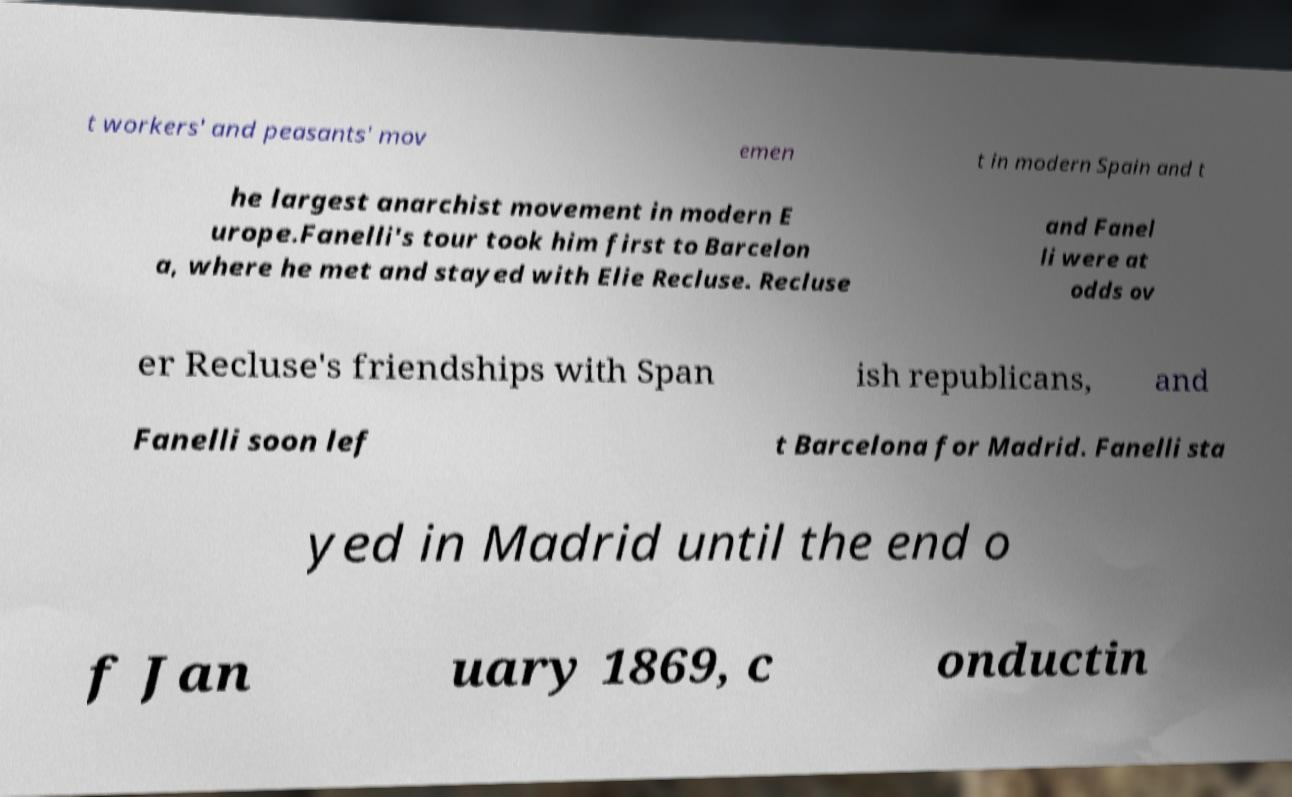What messages or text are displayed in this image? I need them in a readable, typed format. t workers' and peasants' mov emen t in modern Spain and t he largest anarchist movement in modern E urope.Fanelli's tour took him first to Barcelon a, where he met and stayed with Elie Recluse. Recluse and Fanel li were at odds ov er Recluse's friendships with Span ish republicans, and Fanelli soon lef t Barcelona for Madrid. Fanelli sta yed in Madrid until the end o f Jan uary 1869, c onductin 